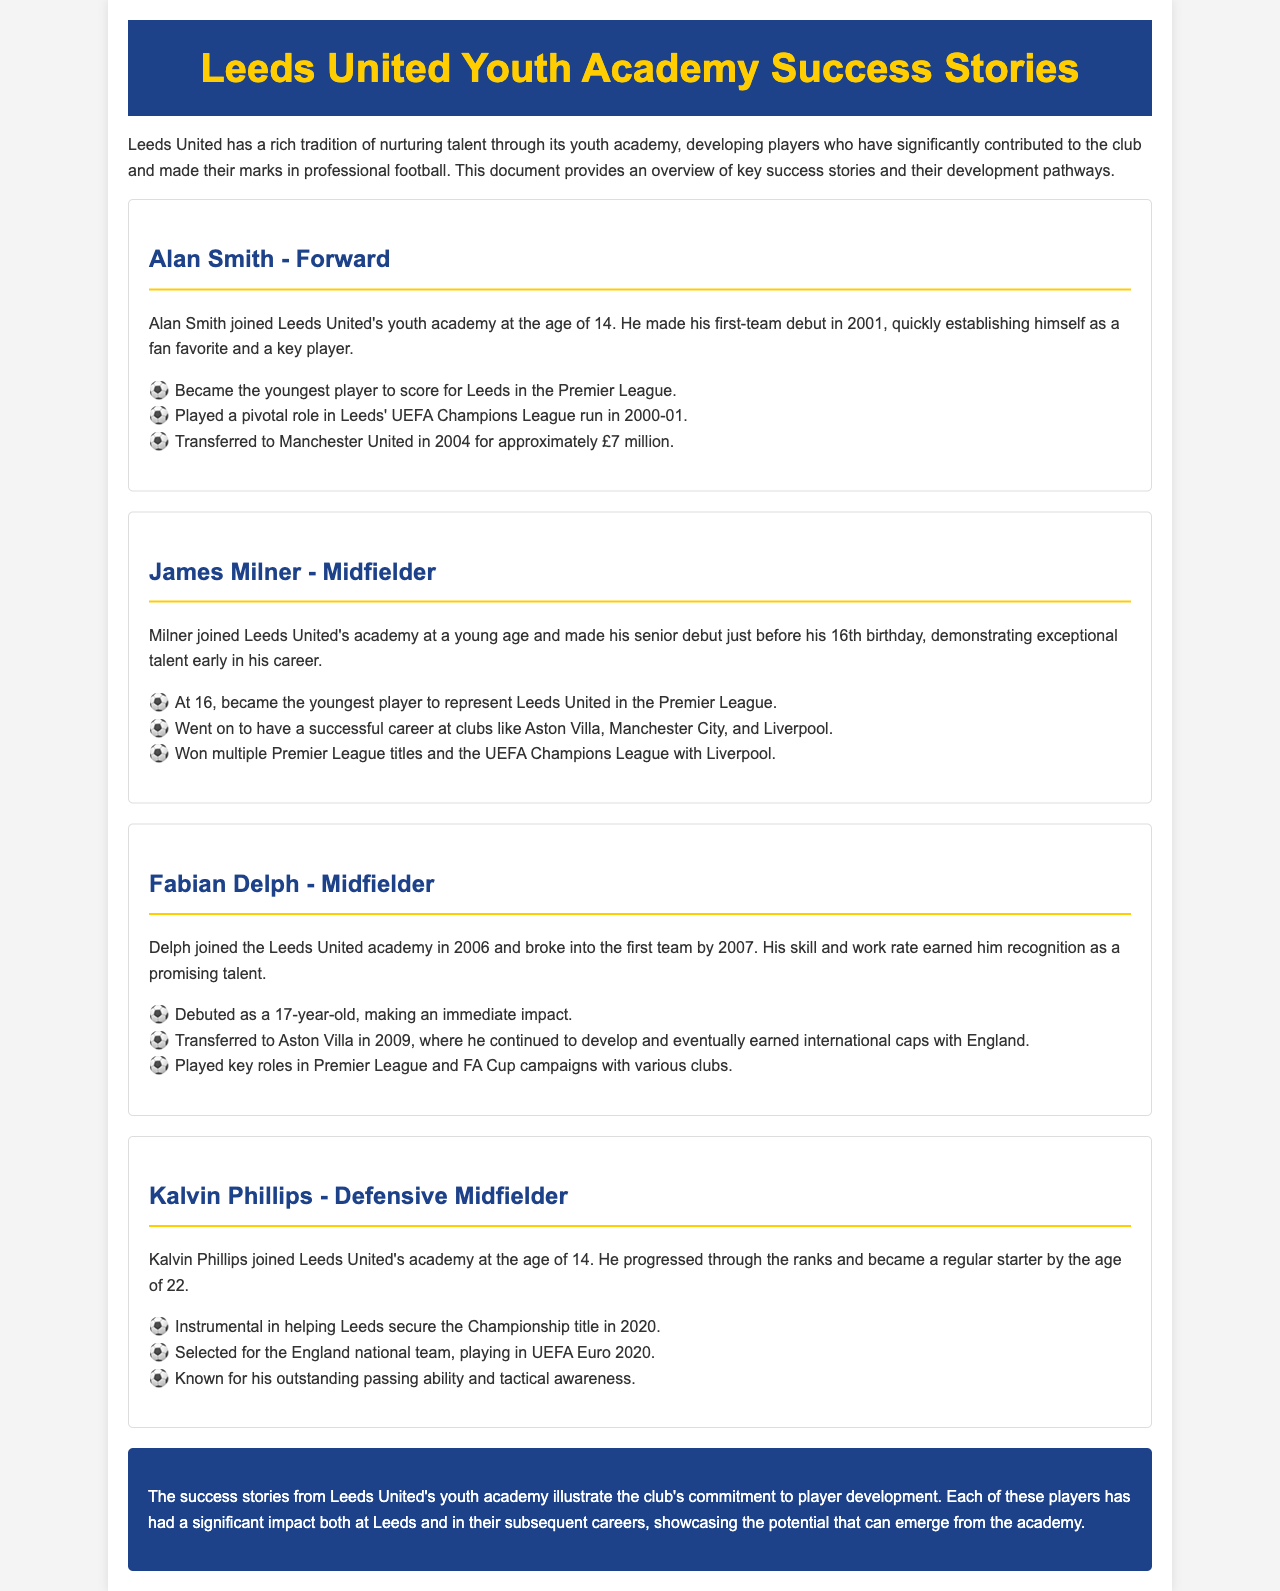What age did Alan Smith join the youth academy? Alan Smith joined Leeds United's youth academy at the age of 14.
Answer: 14 Which player became the youngest to represent Leeds United in the Premier League? James Milner became the youngest player to represent Leeds United in the Premier League at 16.
Answer: James Milner What year did Fabian Delph break into the first team? Fabian Delph broke into the first team by 2007.
Answer: 2007 How much was Alan Smith sold to Manchester United for? Alan Smith was transferred to Manchester United in 2004 for approximately £7 million.
Answer: £7 million What title did Kalvin Phillips help Leeds secure in 2020? Kalvin Phillips was instrumental in helping Leeds secure the Championship title in 2020.
Answer: Championship title What notable achievement did James Milner receive with Liverpool? James Milner won multiple Premier League titles and the UEFA Champions League with Liverpool.
Answer: UEFA Champions League In what year was Alan Smith born? The document does not explicitly state Alan Smith's birth year, but his debut in 2001 implies he was born around 1980.
Answer: Not provided What position did Kalvin Phillips primarily play? Kalvin Phillips is primarily known as a defensive midfielder.
Answer: Defensive Midfielder Which club did Fabian Delph transfer to after Leeds? Fabian Delph transferred to Aston Villa in 2009.
Answer: Aston Villa 